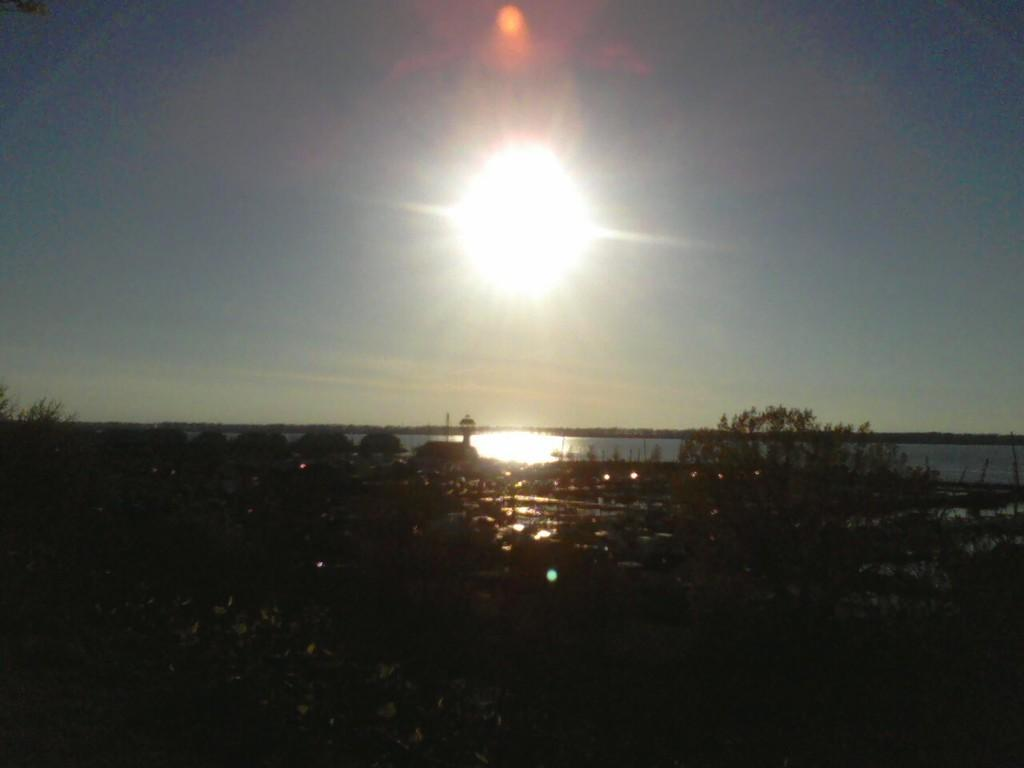Where was the image taken? The image is taken outside. What can be seen at the bottom of the image? There are plants and stones at the bottom of the image. What is the main feature in the center of the image? There is a river in the center of the image. What is visible at the top of the image? The sky is visible at the top of the image. Can you describe the sun's position in the sky? The sun is present in the sky. What is the price of the window in the image? There is no window present in the image, so it is not possible to determine its price. 